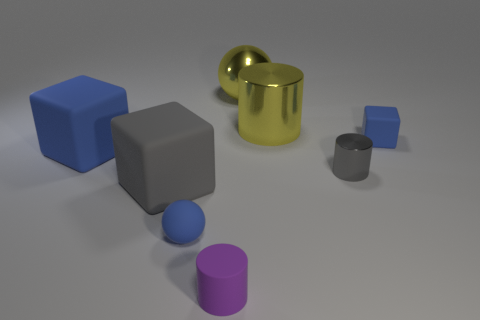How many blue things are small cylinders or large matte blocks?
Your response must be concise. 1. There is a gray cylinder; are there any rubber objects in front of it?
Provide a short and direct response. Yes. What is the size of the matte cylinder?
Offer a very short reply. Small. The yellow thing that is the same shape as the tiny purple thing is what size?
Provide a succinct answer. Large. How many small blocks are in front of the tiny blue thing in front of the big blue cube?
Provide a short and direct response. 0. Do the thing in front of the small blue rubber ball and the big object behind the yellow metal cylinder have the same material?
Provide a succinct answer. No. How many other big things have the same shape as the large gray matte thing?
Keep it short and to the point. 1. How many big metal cylinders are the same color as the big metallic sphere?
Provide a short and direct response. 1. Does the small blue rubber thing that is in front of the small blue rubber cube have the same shape as the tiny matte object that is to the right of the large yellow cylinder?
Keep it short and to the point. No. How many small rubber objects are left of the yellow metallic cylinder that is left of the blue object to the right of the gray shiny cylinder?
Keep it short and to the point. 2. 